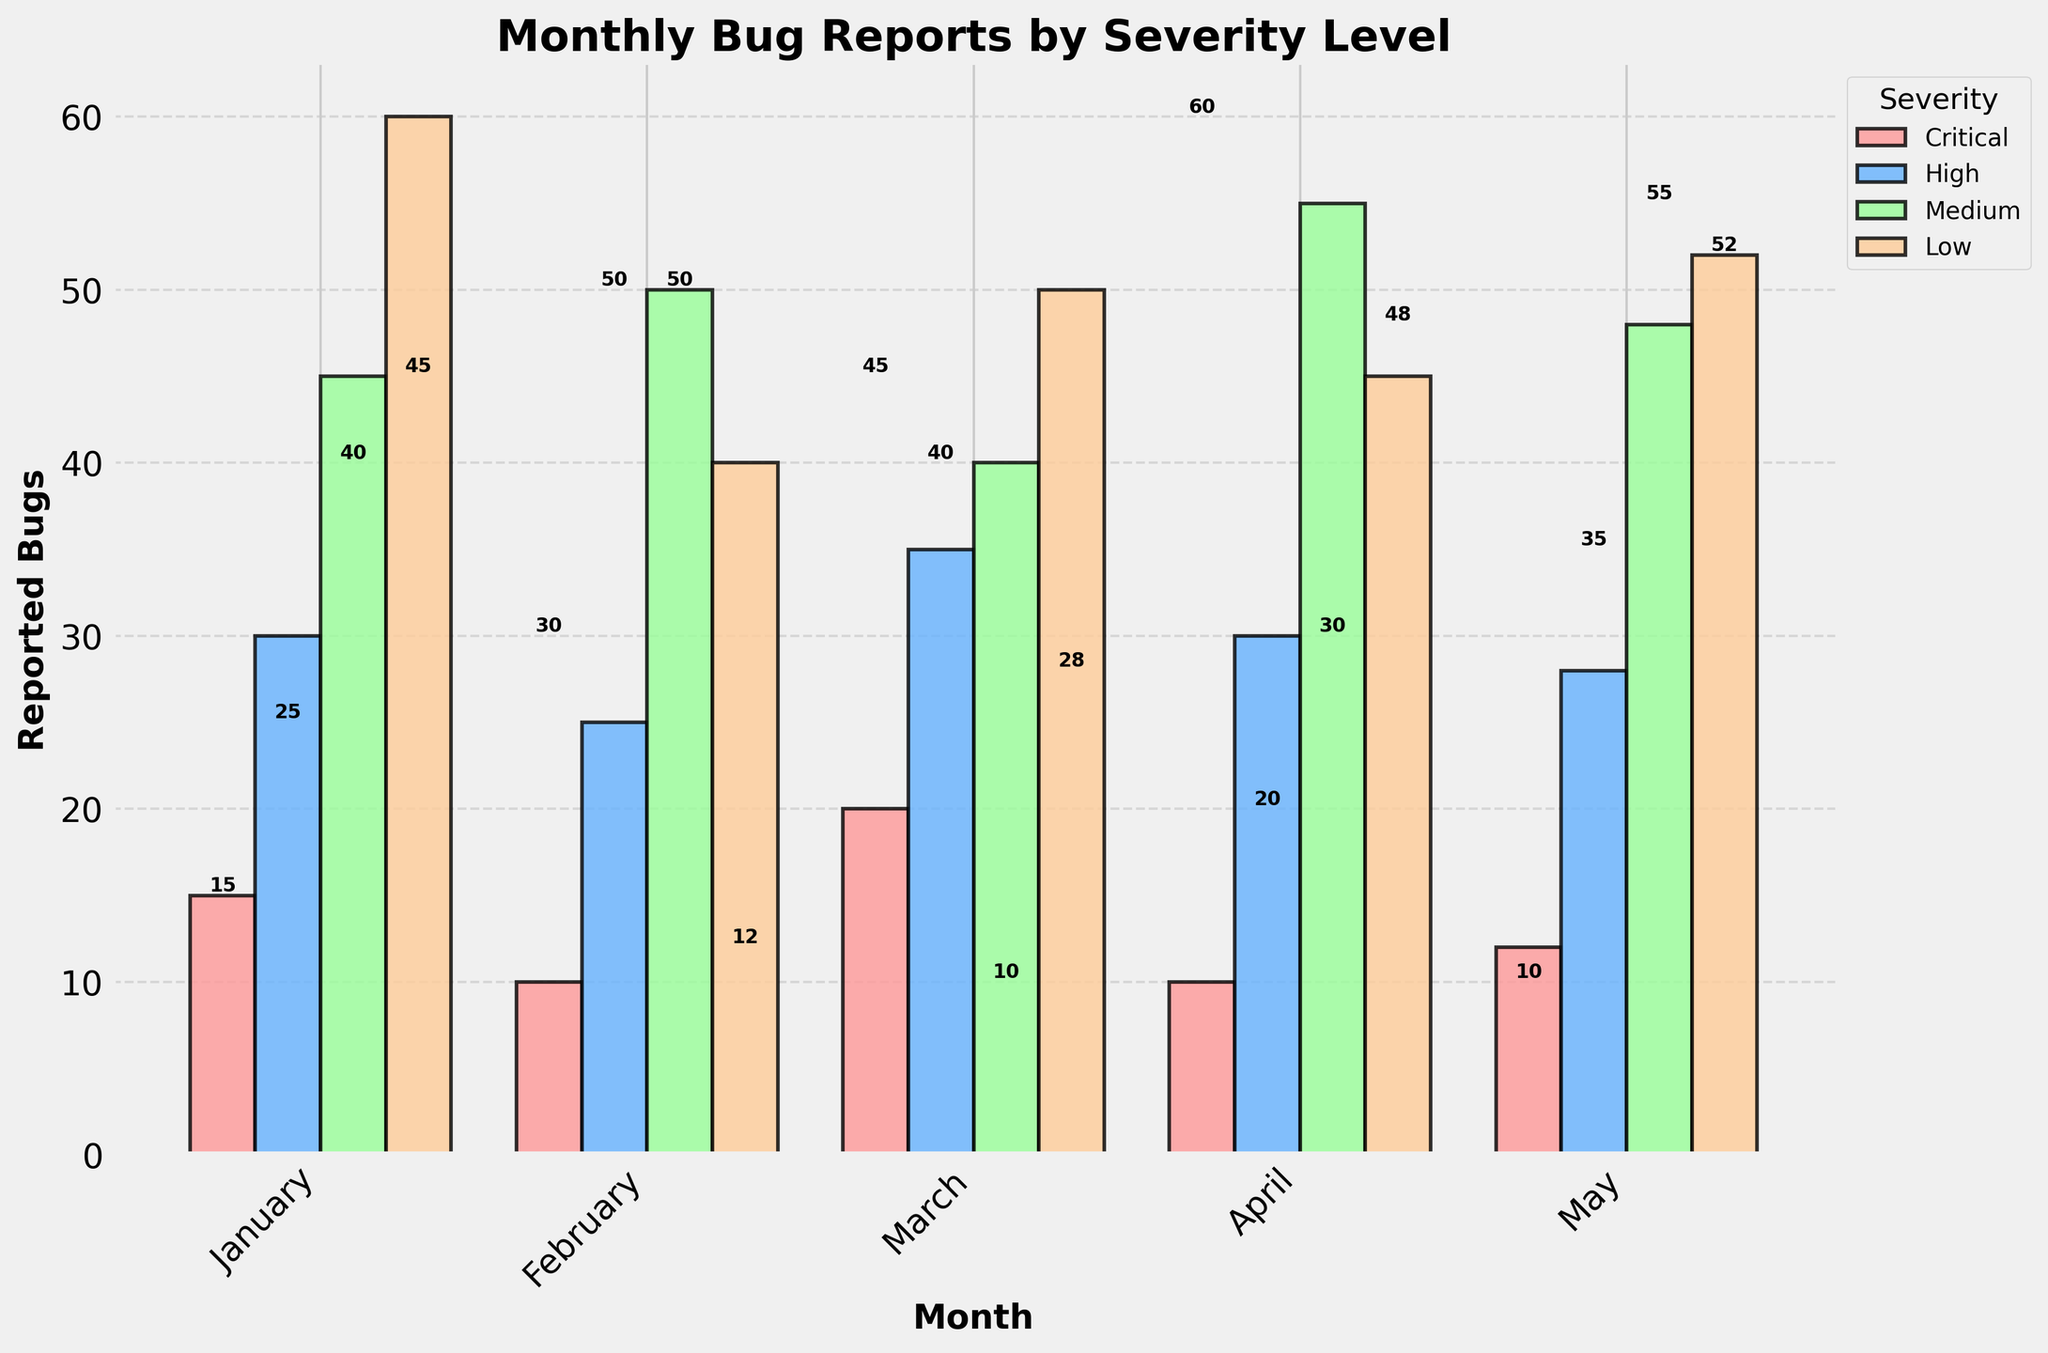What is the title of the figure? The title of the figure is prominently displayed at the top and reads "Monthly Bug Reports by Severity Level".
Answer: Monthly Bug Reports by Severity Level How many months are represented in the figure? The x-axis of the figure lists the months, which include: January, February, March, April, and May. Thus, there are 5 months represented.
Answer: 5 Which severity level had the highest number of reported bugs in January? In January, the highest bar corresponds to the "Low" severity level, which has a value of 60 reported bugs.
Answer: Low What is the overall trend of "Critical" severity bugs from January to May? By examining the "Critical" severity bars for each month, we see that the number of bugs fluctuates: 15 in January, decreases to 10 in February, increases to 20 in March, back to 10 in April, and finally 12 in May. There is no consistent upward or downward trend.
Answer: Fluctuating What is the average number of reported "High" severity bugs across all months? To find the average, sum the reported "High" severity bugs for each month: 30 (Jan) + 25 (Feb) + 35 (Mar) + 30 (Apr) + 28 (May) = 148, and then divide by the number of months (5). 148 / 5 = 29.6
Answer: 29.6 Which month had the highest total number of reported bugs across all severity levels? Summing the reported bugs across all severities for each month: January (15+30+45+60=150), February (10+25+50+40=125), March (20+35+40+50=145), April (10+30+55+45=140), May (12+28+48+52=140). January had the highest total with 150 reported bugs.
Answer: January By how much did the number of "Medium" severity bugs increase or decrease from February to March? For February, "Medium" severity bugs are 50, and for March, they are 40. Thus, the number decreased. The difference is 50 - 40 = 10.
Answer: Decreased by 10 Which severity level had the most consistent number of reported bugs across all months? The consistency can be evaluated by observing the bars' heights. "High" severity has values 30, 25, 35, 30, and 28, which show the least variation.
Answer: High Compare the total number of reported bugs of "Low" severity between the first and last month. "Low" severity in January is 60 and in May is 52. Comparing the two, 60 - 52 = 8.
Answer: 8 fewer in May What was the total number of reported bugs for the "High" severity level in the second half of the data (March to May)? Summing the reported "High" severity bugs for March, April, and May: 35 + 30 + 28 = 93.
Answer: 93 